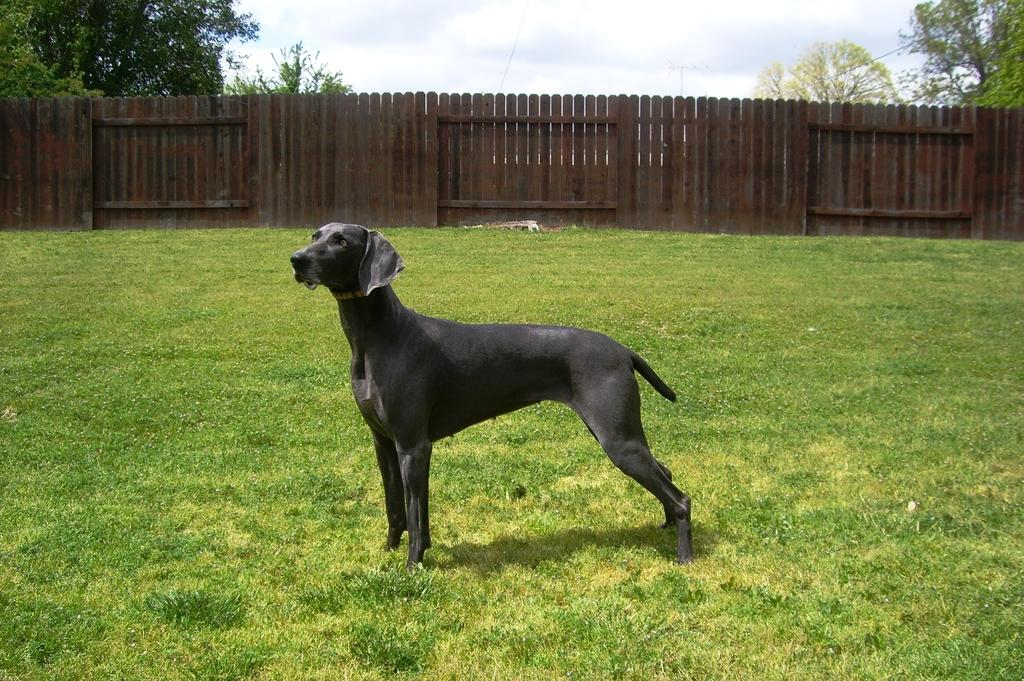What type of animal is in the image? There is a dog in the image. What is at the bottom of the image? There is grass at the bottom of the image. What can be seen in the background of the image? There are trees, fencing, and the sky visible in the background of the image. What is the condition of the sky in the image? The sky is visible in the background of the image, and there are clouds present. What direction is the dog facing in the image? The provided facts do not specify the direction the dog is facing, so it cannot be determined from the image. --- Facts: 1. There is a car in the image. 2. The car is red. 3. There are people in the car. 4. The car has four wheels. 5. The car has a license plate. Absurd Topics: parrot, ocean, volcano Conversation: What is the main subject in the image? There is a car in the image. What color is the car? The car is red. Are there any people inside the car? Yes, there are people in the car. How many wheels does the car have? The car has four wheels. Does the car have a license plate? Yes, the car has a license plate. Reasoning: Let's think step by step in order to produce the conversation. We start by identifying the main subject of the image, which is the car. Next, we describe specific features of the car, such as its color, the presence of people inside the car, the number of wheels it has, and the presence of a license plate. Finally, we ensure that the language is simple and clear. Absurd Question/Answer: Can you see a parrot flying over the car in the image? No, there is no parrot visible in the image. --- Facts: 1. There is a cat in the image. 2. The cat is black and white. 3. The cat is sitting on a windowsill. 4. There is a birdcage in the background of the image. 5. The birdcage is empty. Absurd Topics: unicorn, rainbow, magic Conversation: What type of animal is in the image? There is a cat in the image. What is the color pattern of the cat? The cat is black and white. Where is the cat located in the image? The cat is sitting on a windowsill. What can be seen in the background of the image? There is a birdcage in the background of the image. Is there a bird inside the birdcage in the image? No, the birdcage is empty. Reasoning: Let's think step by step in order to produce the conversation. We start by identifying the main subject of the image, 